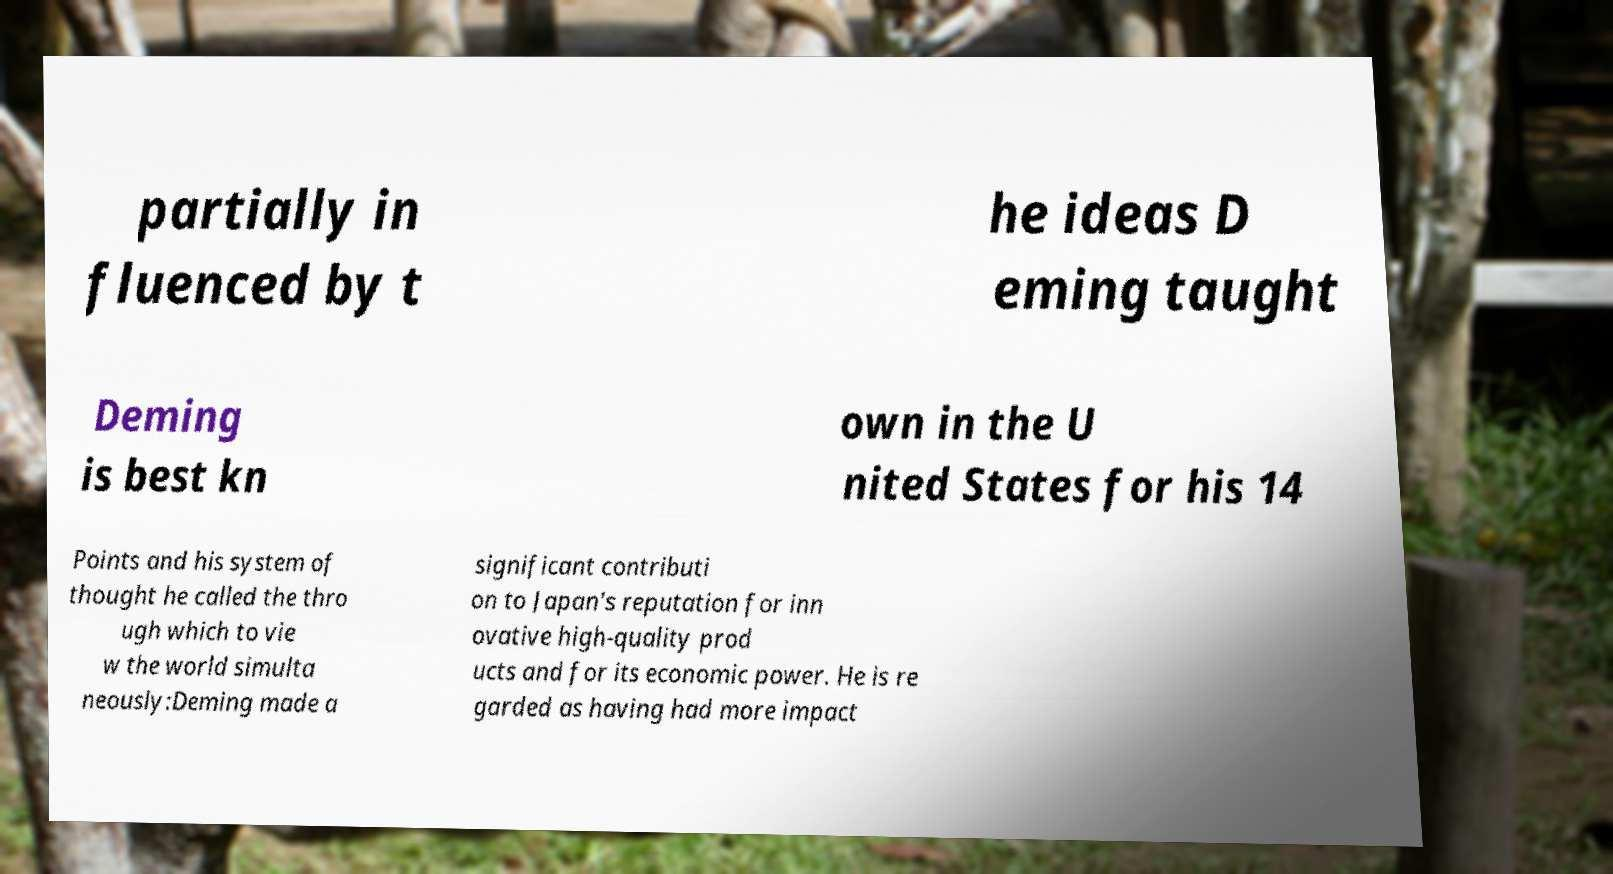Could you extract and type out the text from this image? partially in fluenced by t he ideas D eming taught Deming is best kn own in the U nited States for his 14 Points and his system of thought he called the thro ugh which to vie w the world simulta neously:Deming made a significant contributi on to Japan's reputation for inn ovative high-quality prod ucts and for its economic power. He is re garded as having had more impact 